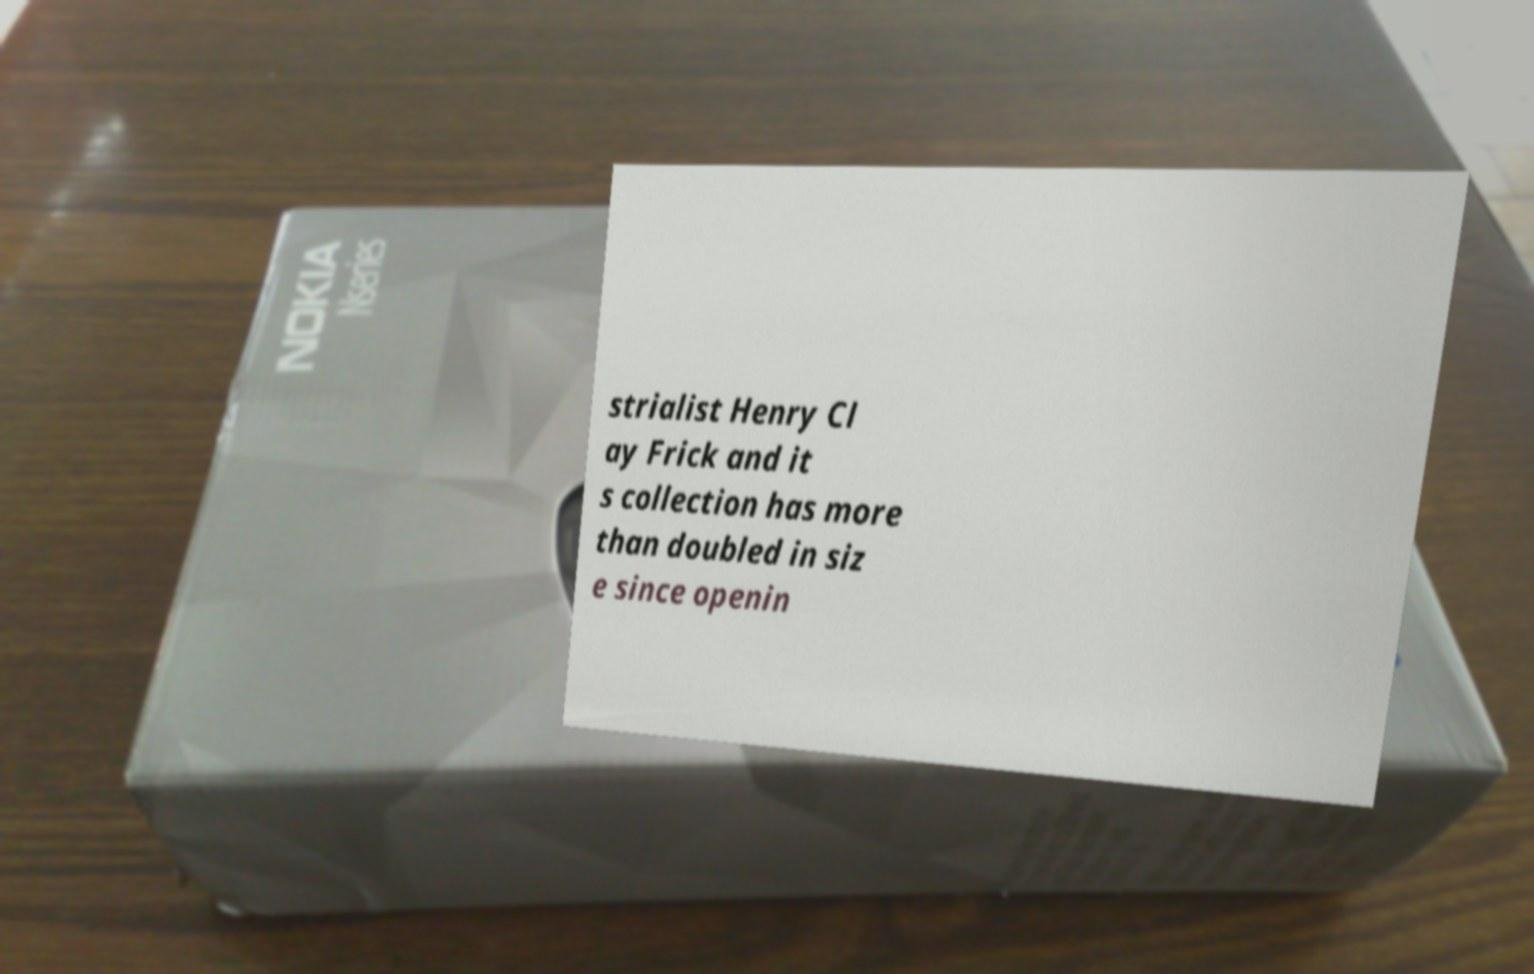Please read and relay the text visible in this image. What does it say? strialist Henry Cl ay Frick and it s collection has more than doubled in siz e since openin 